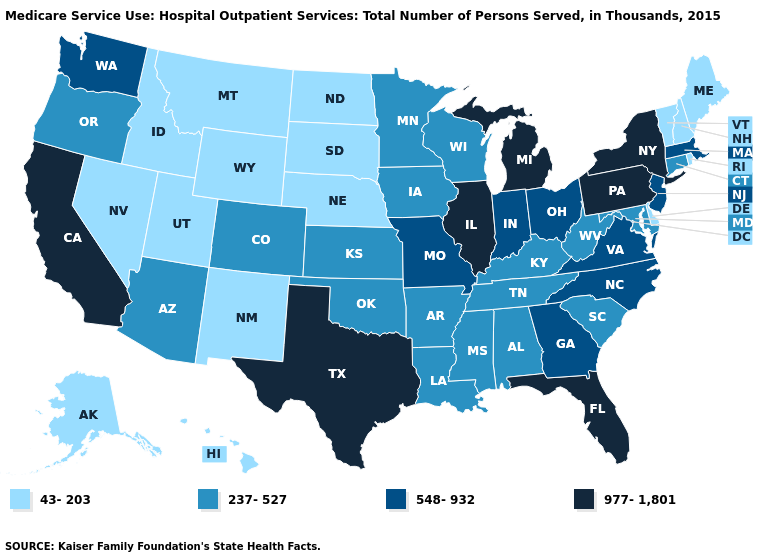What is the value of Texas?
Give a very brief answer. 977-1,801. Does the map have missing data?
Keep it brief. No. Does the map have missing data?
Be succinct. No. Name the states that have a value in the range 43-203?
Answer briefly. Alaska, Delaware, Hawaii, Idaho, Maine, Montana, Nebraska, Nevada, New Hampshire, New Mexico, North Dakota, Rhode Island, South Dakota, Utah, Vermont, Wyoming. Does Utah have the lowest value in the USA?
Answer briefly. Yes. Name the states that have a value in the range 977-1,801?
Be succinct. California, Florida, Illinois, Michigan, New York, Pennsylvania, Texas. Does Georgia have the lowest value in the South?
Short answer required. No. Name the states that have a value in the range 43-203?
Write a very short answer. Alaska, Delaware, Hawaii, Idaho, Maine, Montana, Nebraska, Nevada, New Hampshire, New Mexico, North Dakota, Rhode Island, South Dakota, Utah, Vermont, Wyoming. Does Alaska have the highest value in the West?
Concise answer only. No. Does the first symbol in the legend represent the smallest category?
Be succinct. Yes. What is the lowest value in the Northeast?
Keep it brief. 43-203. What is the highest value in states that border Arkansas?
Answer briefly. 977-1,801. What is the lowest value in the USA?
Quick response, please. 43-203. What is the value of Nebraska?
Write a very short answer. 43-203. Name the states that have a value in the range 43-203?
Write a very short answer. Alaska, Delaware, Hawaii, Idaho, Maine, Montana, Nebraska, Nevada, New Hampshire, New Mexico, North Dakota, Rhode Island, South Dakota, Utah, Vermont, Wyoming. 